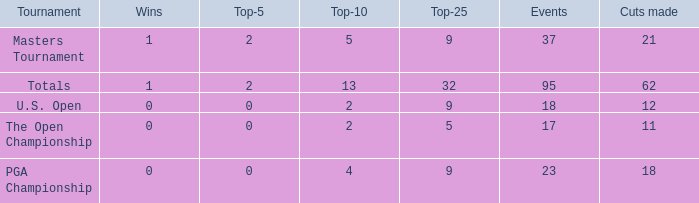What is the lowest top 5 winners with less than 0? None. 